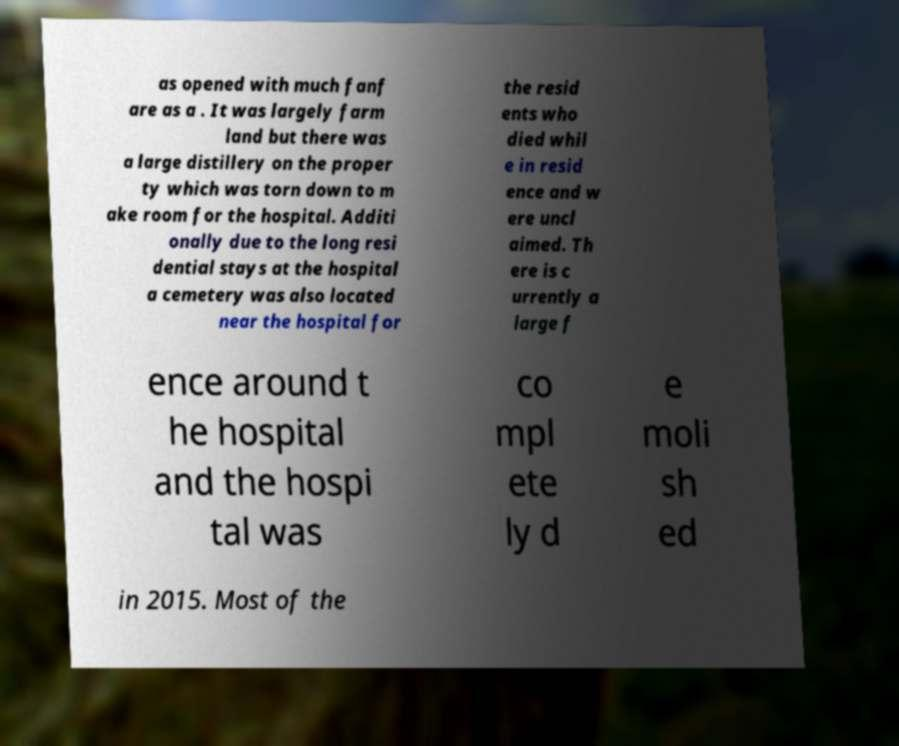I need the written content from this picture converted into text. Can you do that? as opened with much fanf are as a . It was largely farm land but there was a large distillery on the proper ty which was torn down to m ake room for the hospital. Additi onally due to the long resi dential stays at the hospital a cemetery was also located near the hospital for the resid ents who died whil e in resid ence and w ere uncl aimed. Th ere is c urrently a large f ence around t he hospital and the hospi tal was co mpl ete ly d e moli sh ed in 2015. Most of the 